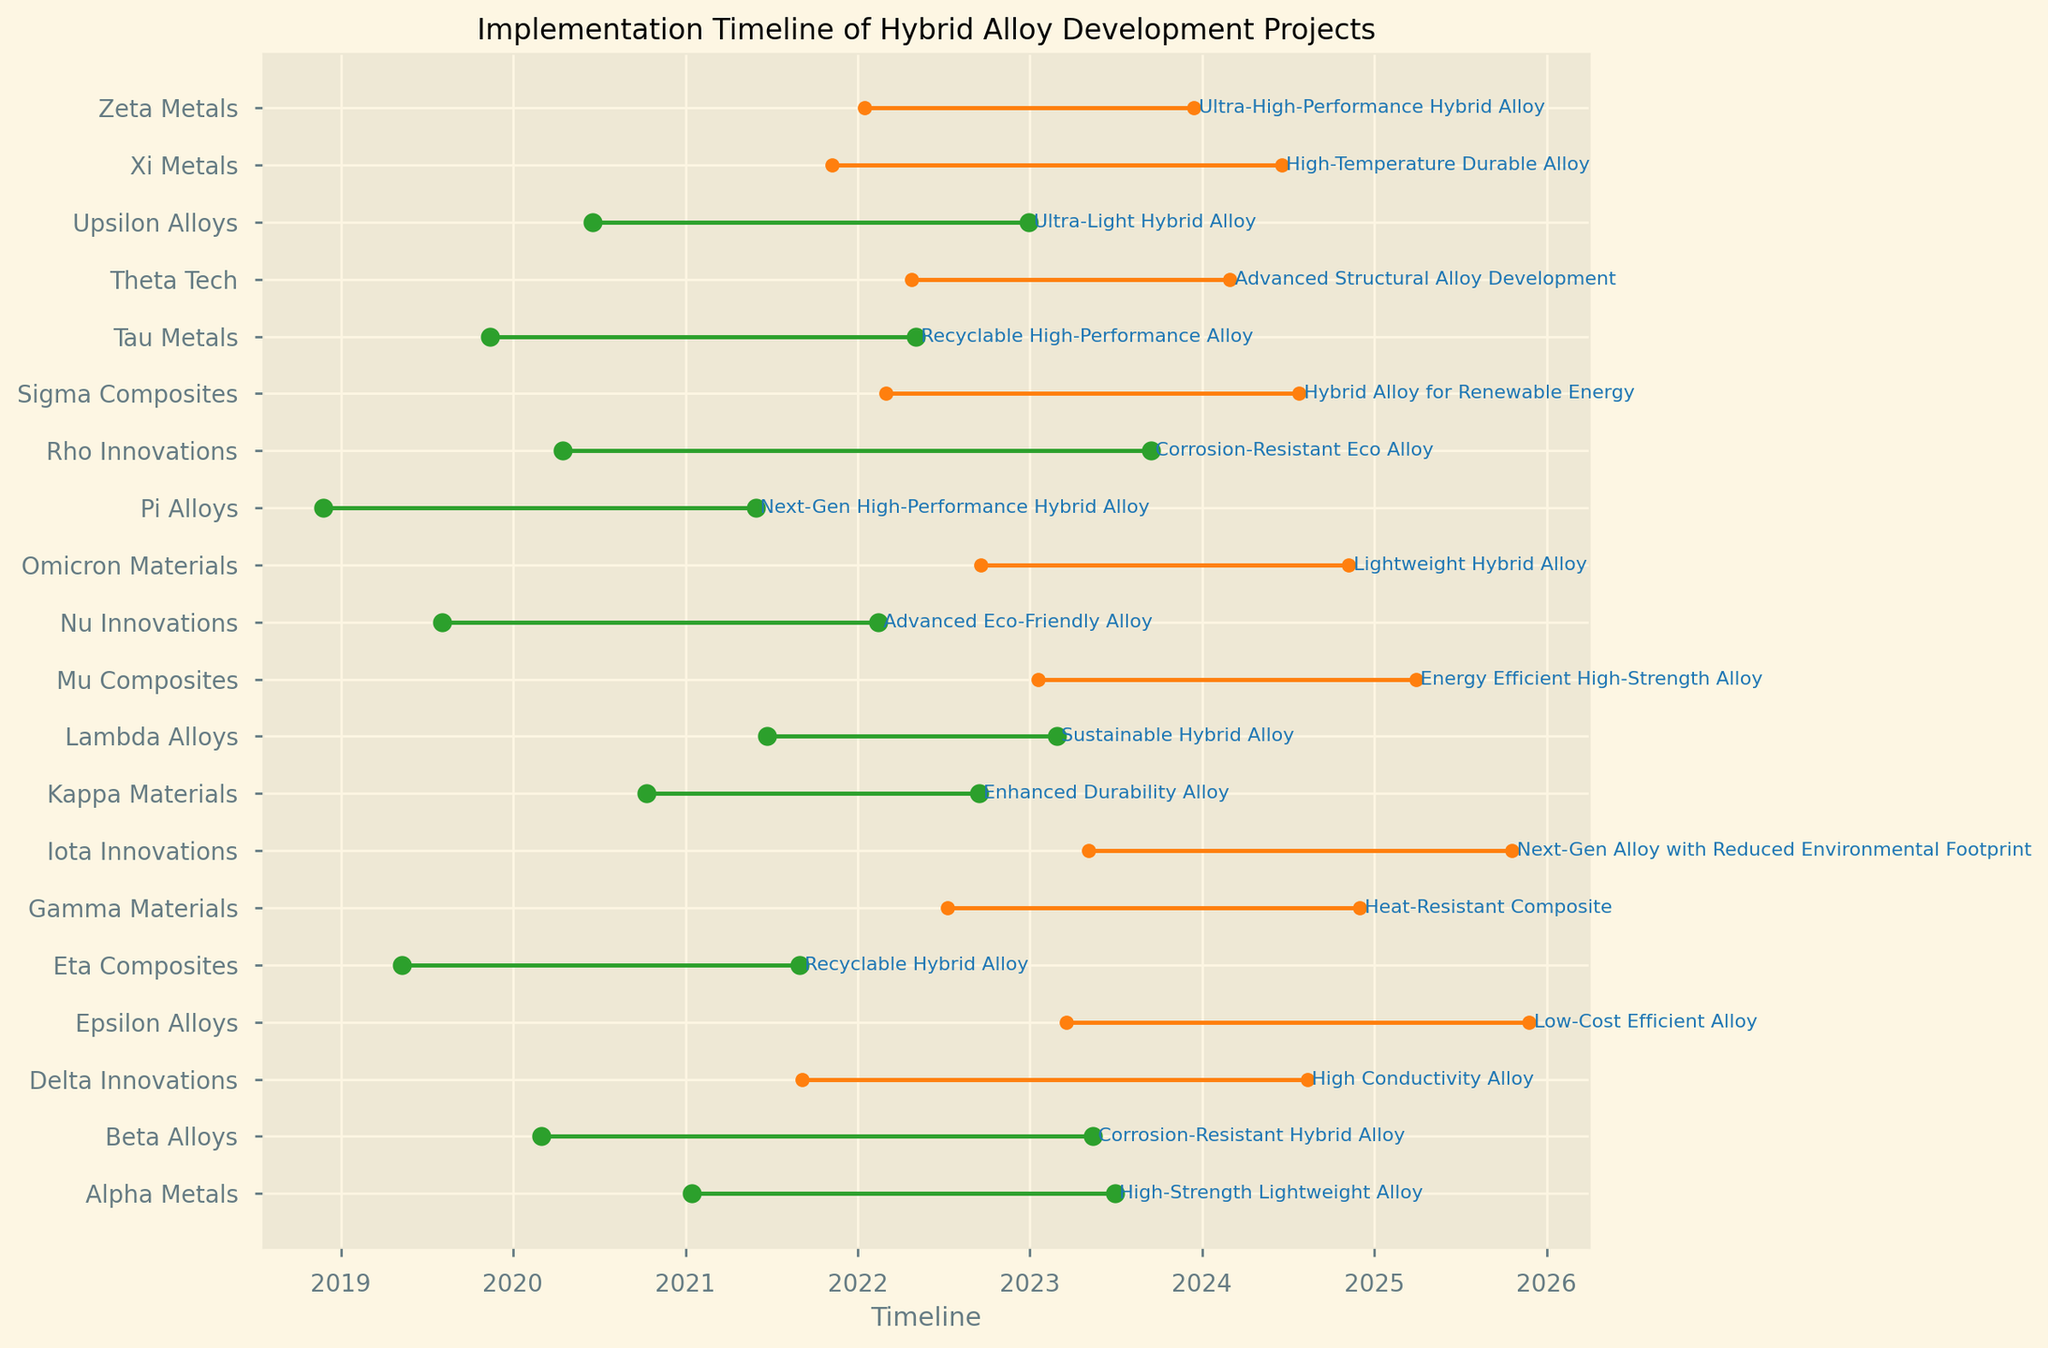Which company has the most projects in progress? Look for the company names that have the most lines in progress (orange lines without filled markers). Count the occurrences for each company.
Answer: Gamma Materials and Delta Innovations How many projects have been completed by 2023-06-30? Check the project lines that end before or on 2023-06-30 and have the 'Completed' status (indicated by filled green markers).
Answer: 10 Which project took the longest time to complete, and which company undertook it? Measure the length in timeline of all lines with 'Completed' status. Compare the start and end dates for each and identify the longest one.
Answer: Recyclable Hybrid Alloy, Eta Composites Which company has the latest planned start date for a project? Check the timelines for projects with status 'Planned' and identify the one with the latest start date.
Answer: Iota Innovations How many companies have more than one project listed? Look at the plot and count the companies which have more than one line (different projects).
Answer: 4 Which project has the shortest duration among those in progress? Compare the lengths of the lines marked in progress (orange lines without filled markers) and identify the shortest one.
Answer: Ultra-High-Performance Hybrid Alloy, Zeta Metals How many projects are planned to end after 2024? Identify all lines that extend into 2025 in the timeline and have a 'Planned' status (orange lines without filled markers).
Answer: 3 Which company has projects that span before and after 2023? Look for companies with lines starting before 2023 and extending after 2023 (crossing the 2023 mark on the timeline).
Answer: Delta Innovations Is there any company that has completed exactly one project and is currently working on another one? Check companies that have one line with 'Completed' status and another line with 'In Progress' status.
Answer: Xi Metals Among the ongoing projects, which will intersect first with a completed project? Look for the 'In Progress' lines and see which is closer to intersecting the timeline of a 'Completed' project.
Answer: Heat-Resistant Composite, Gamma Materials 